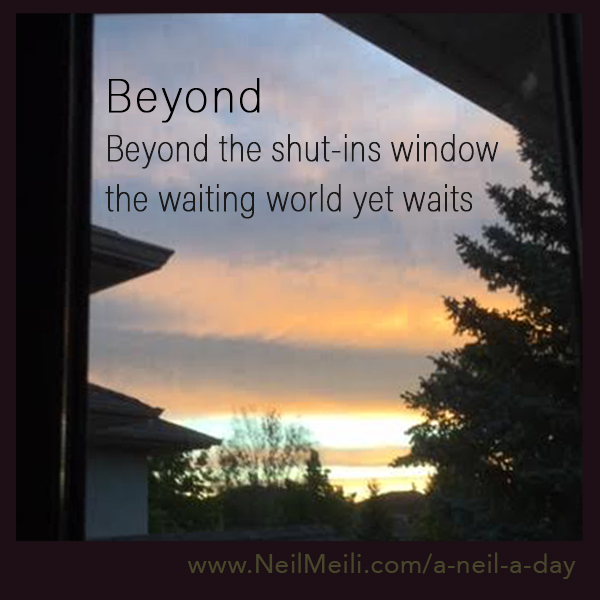What can you infer about the season based on this image? Based on the lush greenery and the partly cloudy sky, it is likely that the image was taken during late spring or early summer. The vibrant colors and healthy plants suggest a time of growth and renewal. 